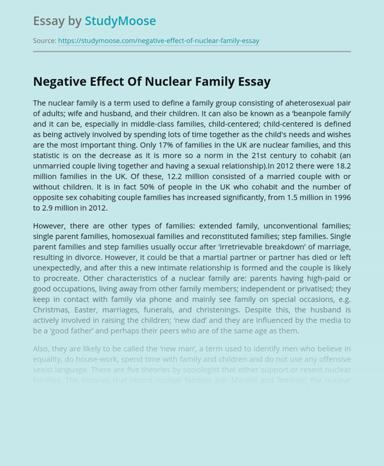In the essay, what is the change that people have observed in family structures in the 21st century? In the 21st century, there has been a noticeable decrease in traditional nuclear families, characterized by a married heterosexual pair with their children. Instead, there's an increase in cohabiting couples without marriage, reflecting a broader acceptance of diverse family configurations. 